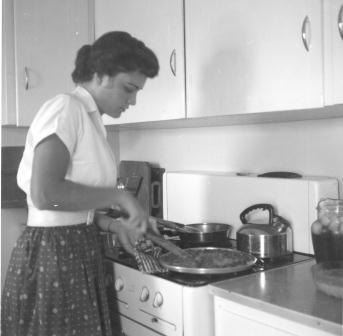What emotion is she experiencing?
Concise answer only. Calm. Does the pitcher have ice cubes in it?
Answer briefly. Yes. What colors are in this photo?
Concise answer only. Black and white. 